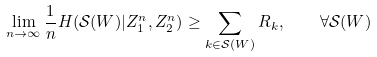Convert formula to latex. <formula><loc_0><loc_0><loc_500><loc_500>\lim _ { n \rightarrow \infty } \frac { 1 } { n } H ( \mathcal { S } ( W ) | Z _ { 1 } ^ { n } , Z _ { 2 } ^ { n } ) \geq \sum _ { k \in \mathcal { S } ( W ) } R _ { k } , \quad \forall \mathcal { S } ( W )</formula> 